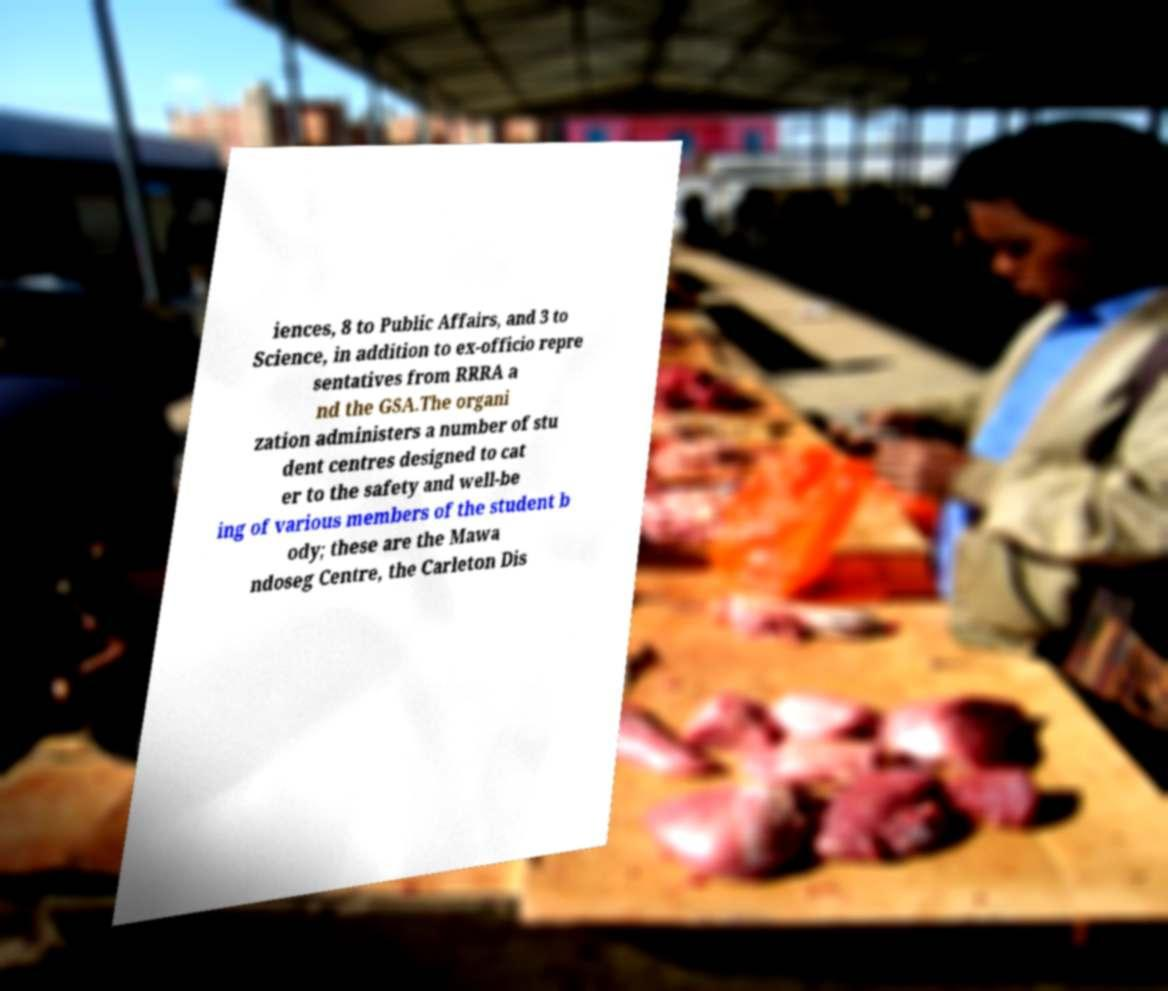I need the written content from this picture converted into text. Can you do that? iences, 8 to Public Affairs, and 3 to Science, in addition to ex-officio repre sentatives from RRRA a nd the GSA.The organi zation administers a number of stu dent centres designed to cat er to the safety and well-be ing of various members of the student b ody; these are the Mawa ndoseg Centre, the Carleton Dis 